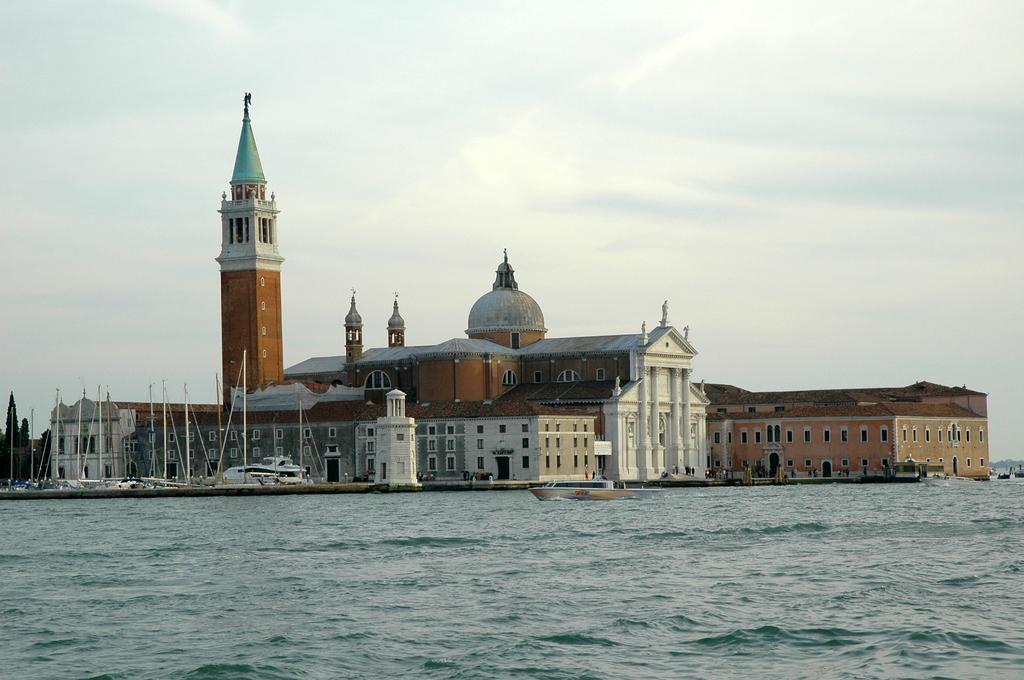Could you give a brief overview of what you see in this image? In this picture I can see the water at the bottom, in the middle there are boats and buildings. At the top I can see the sky. 